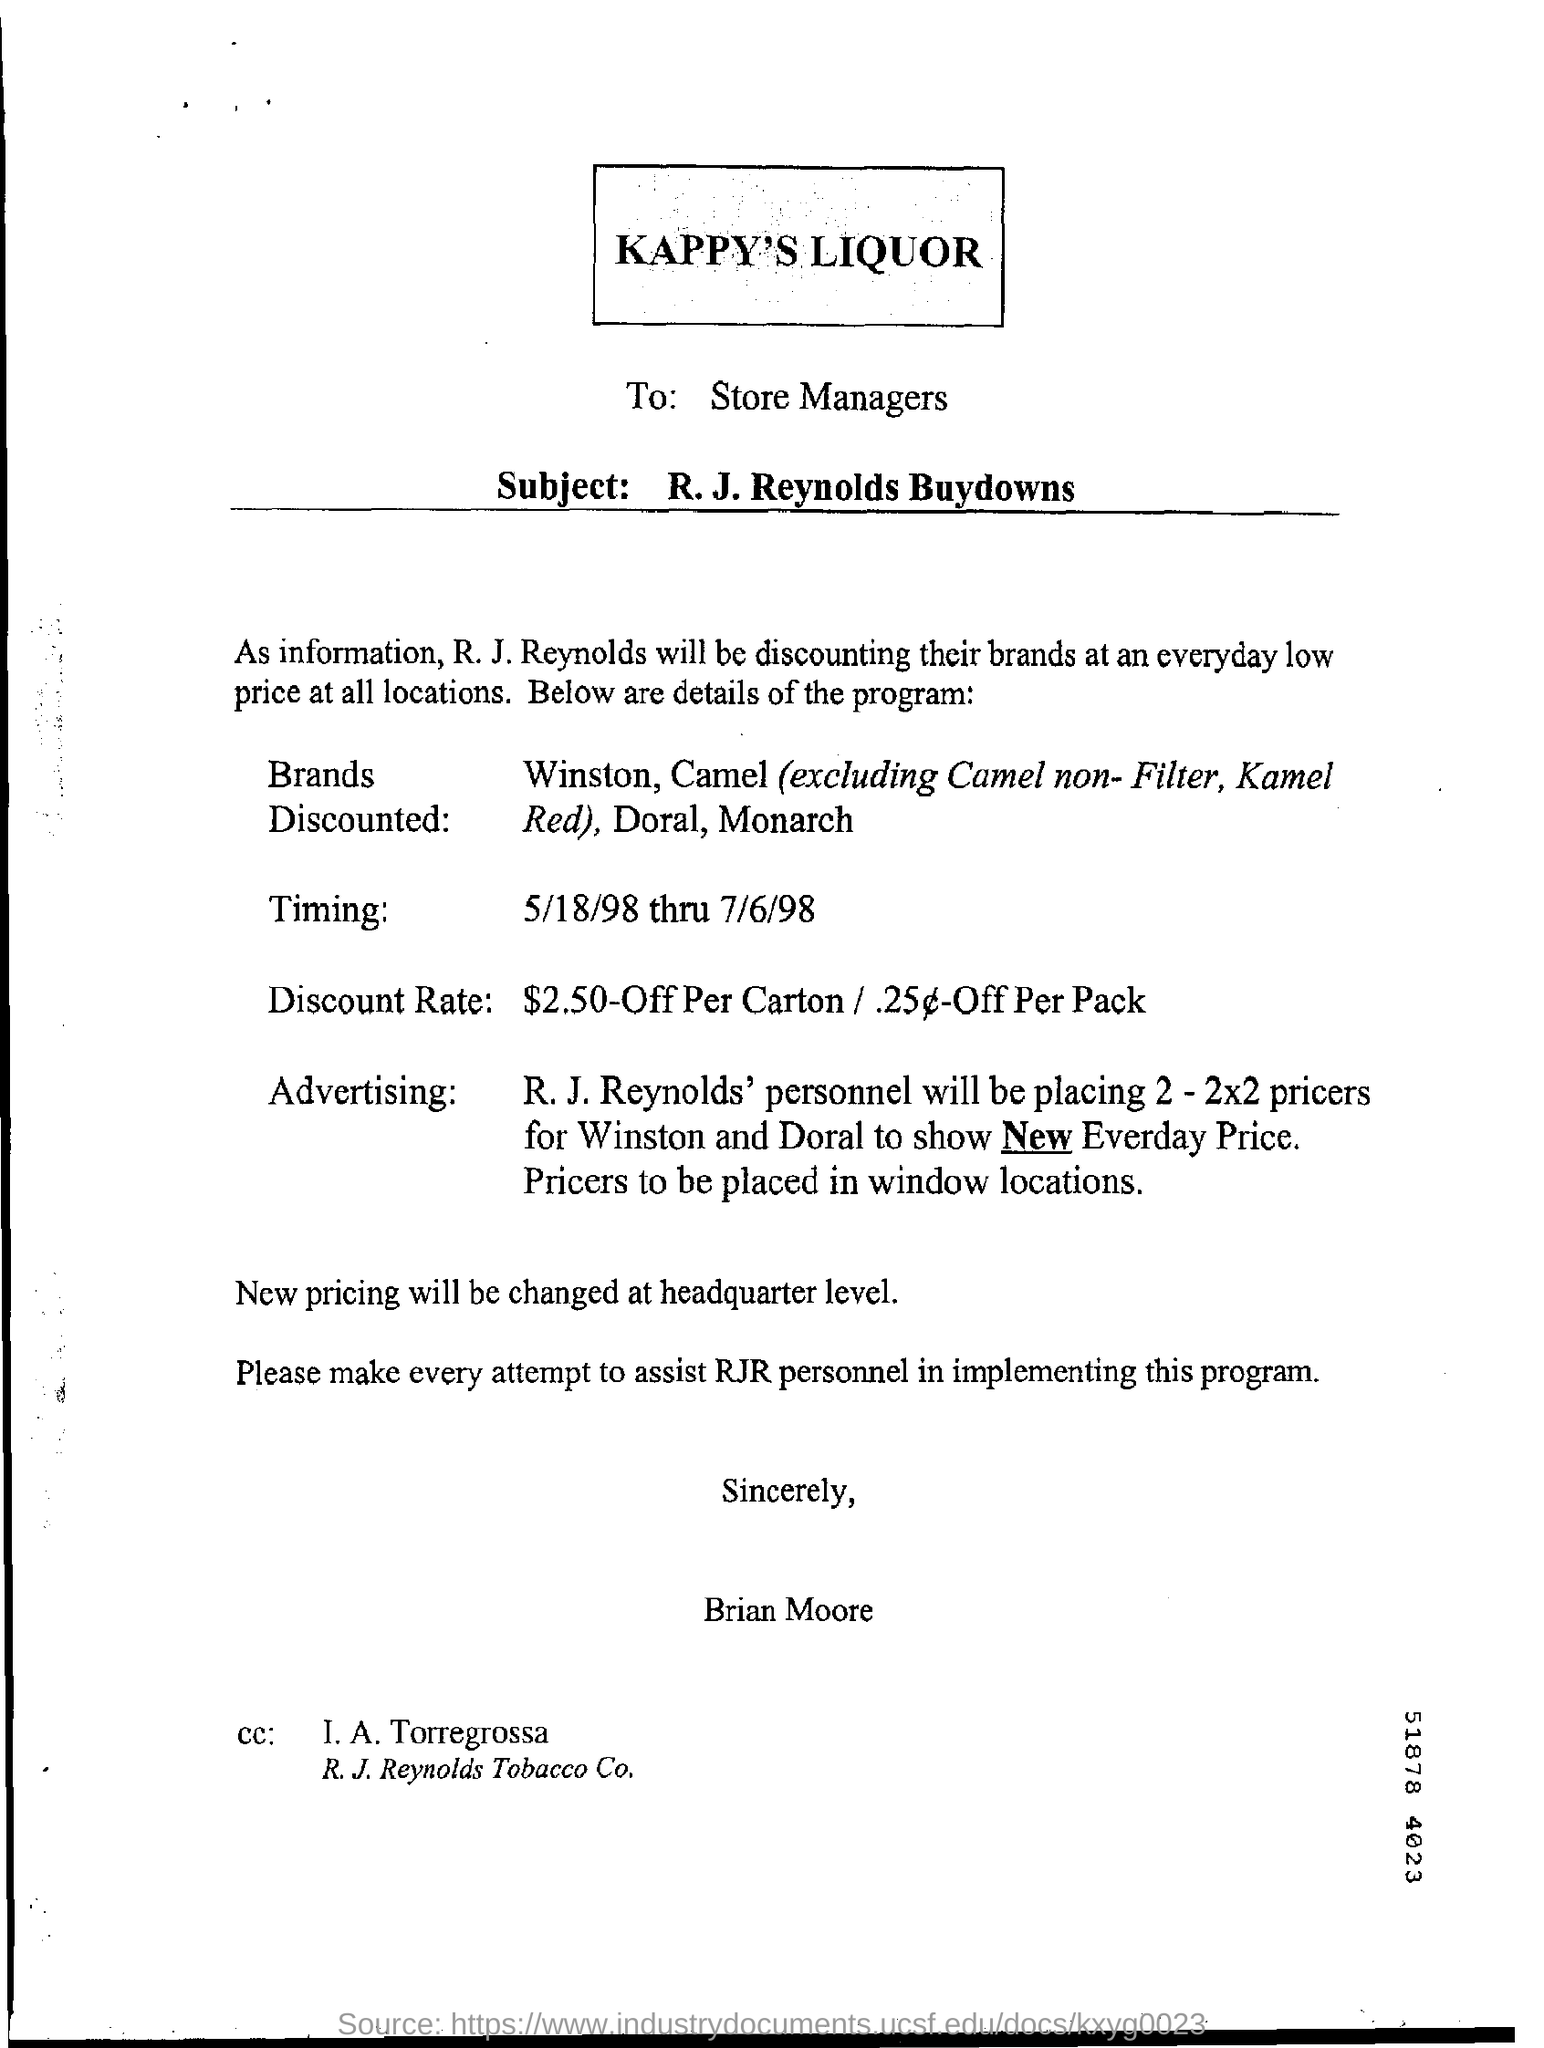Highlight a few significant elements in this photo. The dates mentioned are from 5/18/98 to 7/6/98. The letter was written to the store managers. 